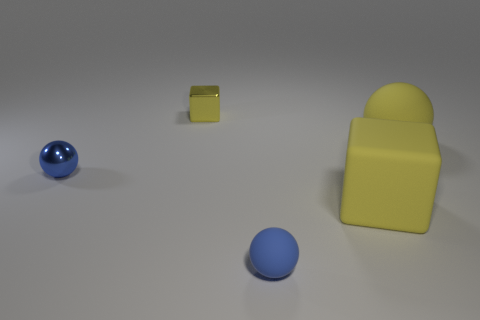What size is the yellow rubber thing that is the same shape as the tiny blue metal thing?
Make the answer very short. Large. The other small object that is the same shape as the blue rubber object is what color?
Your answer should be compact. Blue. Is there a yellow rubber object that has the same shape as the small blue matte thing?
Give a very brief answer. Yes. What number of small yellow cubes are behind the tiny rubber sphere?
Give a very brief answer. 1. What is the material of the blue object that is in front of the tiny blue ball left of the small matte object?
Make the answer very short. Rubber. Are there any other spheres of the same color as the metallic sphere?
Give a very brief answer. Yes. What is the size of the block that is the same material as the big yellow sphere?
Keep it short and to the point. Large. Is there any other thing of the same color as the big rubber sphere?
Offer a very short reply. Yes. What color is the matte ball right of the small matte sphere?
Your answer should be very brief. Yellow. There is a rubber sphere on the left side of the thing to the right of the large yellow cube; are there any yellow matte objects that are on the right side of it?
Give a very brief answer. Yes. 